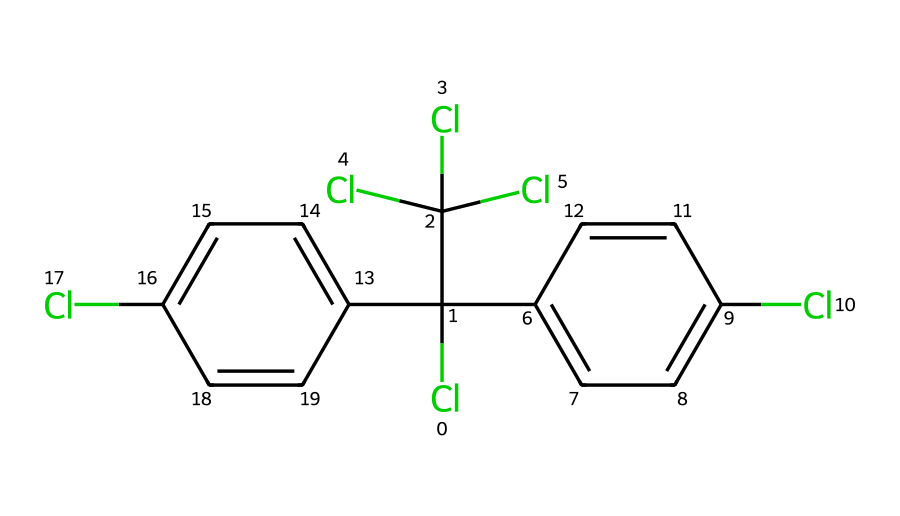What is the name of this chemical? The chemical represented by the SMILES notation is DDT, which stands for dichlorodiphenyltrichloroethane. It is a well-known pesticide.
Answer: DDT How many chlorine atoms are in this molecule? Counting the chlorine (Cl) atoms from the structure, there are four chlorine atoms attached to different parts of the chemical structure.
Answer: four What is the total number of carbon atoms in the molecular structure? By analyzing the SMILES representation, there are twelve carbon (C) atoms in total when counting the carbon atoms present in both phenyl rings and the remaining carbon atoms in the aliphatic part of the molecule.
Answer: twelve What functional groups are present in this pesticide? This pesticide has multiple chlorine substituents and aromatic rings indicating that it is substituted at various positions, with the primary functional group being the alkyl chlorides present in the structure.
Answer: alkyl chlorides Can DDT persist in the atmosphere? Due to its high lipid solubility and low degradation rates in the environment, DDT can persist in the atmosphere for extended periods, often leading to bioaccumulation in organisms.
Answer: yes What is the environmental impact of DDT's persistence? The persistence of DDT in the environment leads to detrimental effects such as bioaccumulation in the food chain, which can cause harm to wildlife and potentially humans through indirect exposure.
Answer: bioaccumulation How many rings are present in the chemical structure? There are two aromatic rings in the structure, which are identified as phenyl groups in the chemical representation of DDT.
Answer: two 